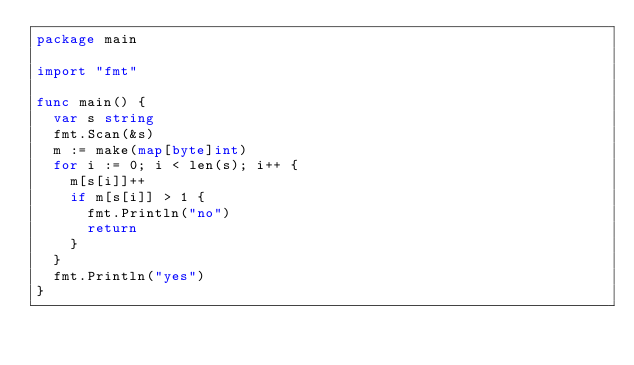Convert code to text. <code><loc_0><loc_0><loc_500><loc_500><_Go_>package main

import "fmt"

func main() {
	var s string
	fmt.Scan(&s)
	m := make(map[byte]int)
	for i := 0; i < len(s); i++ {
		m[s[i]]++
		if m[s[i]] > 1 {
			fmt.Println("no")
			return
		}
	}
	fmt.Println("yes")
}
</code> 